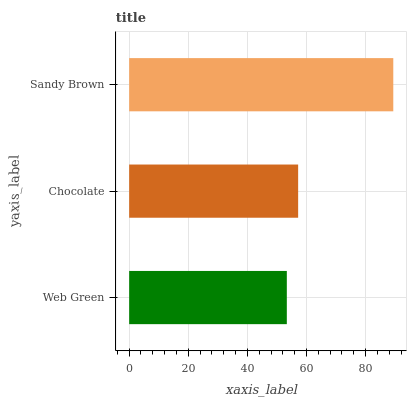Is Web Green the minimum?
Answer yes or no. Yes. Is Sandy Brown the maximum?
Answer yes or no. Yes. Is Chocolate the minimum?
Answer yes or no. No. Is Chocolate the maximum?
Answer yes or no. No. Is Chocolate greater than Web Green?
Answer yes or no. Yes. Is Web Green less than Chocolate?
Answer yes or no. Yes. Is Web Green greater than Chocolate?
Answer yes or no. No. Is Chocolate less than Web Green?
Answer yes or no. No. Is Chocolate the high median?
Answer yes or no. Yes. Is Chocolate the low median?
Answer yes or no. Yes. Is Web Green the high median?
Answer yes or no. No. Is Sandy Brown the low median?
Answer yes or no. No. 